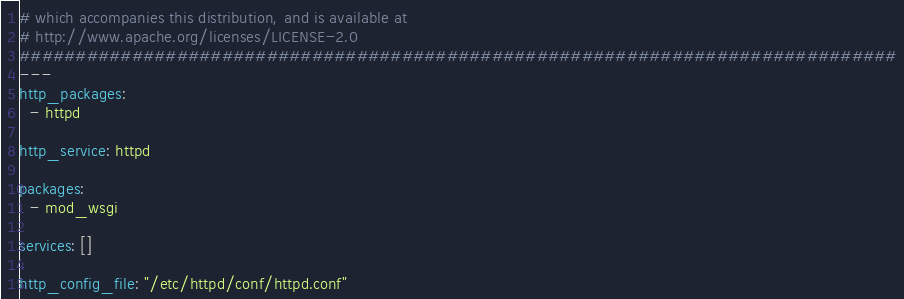<code> <loc_0><loc_0><loc_500><loc_500><_YAML_># which accompanies this distribution, and is available at
# http://www.apache.org/licenses/LICENSE-2.0
##############################################################################
---
http_packages:
  - httpd

http_service: httpd

packages:
  - mod_wsgi

services: []

http_config_file: "/etc/httpd/conf/httpd.conf"
</code> 